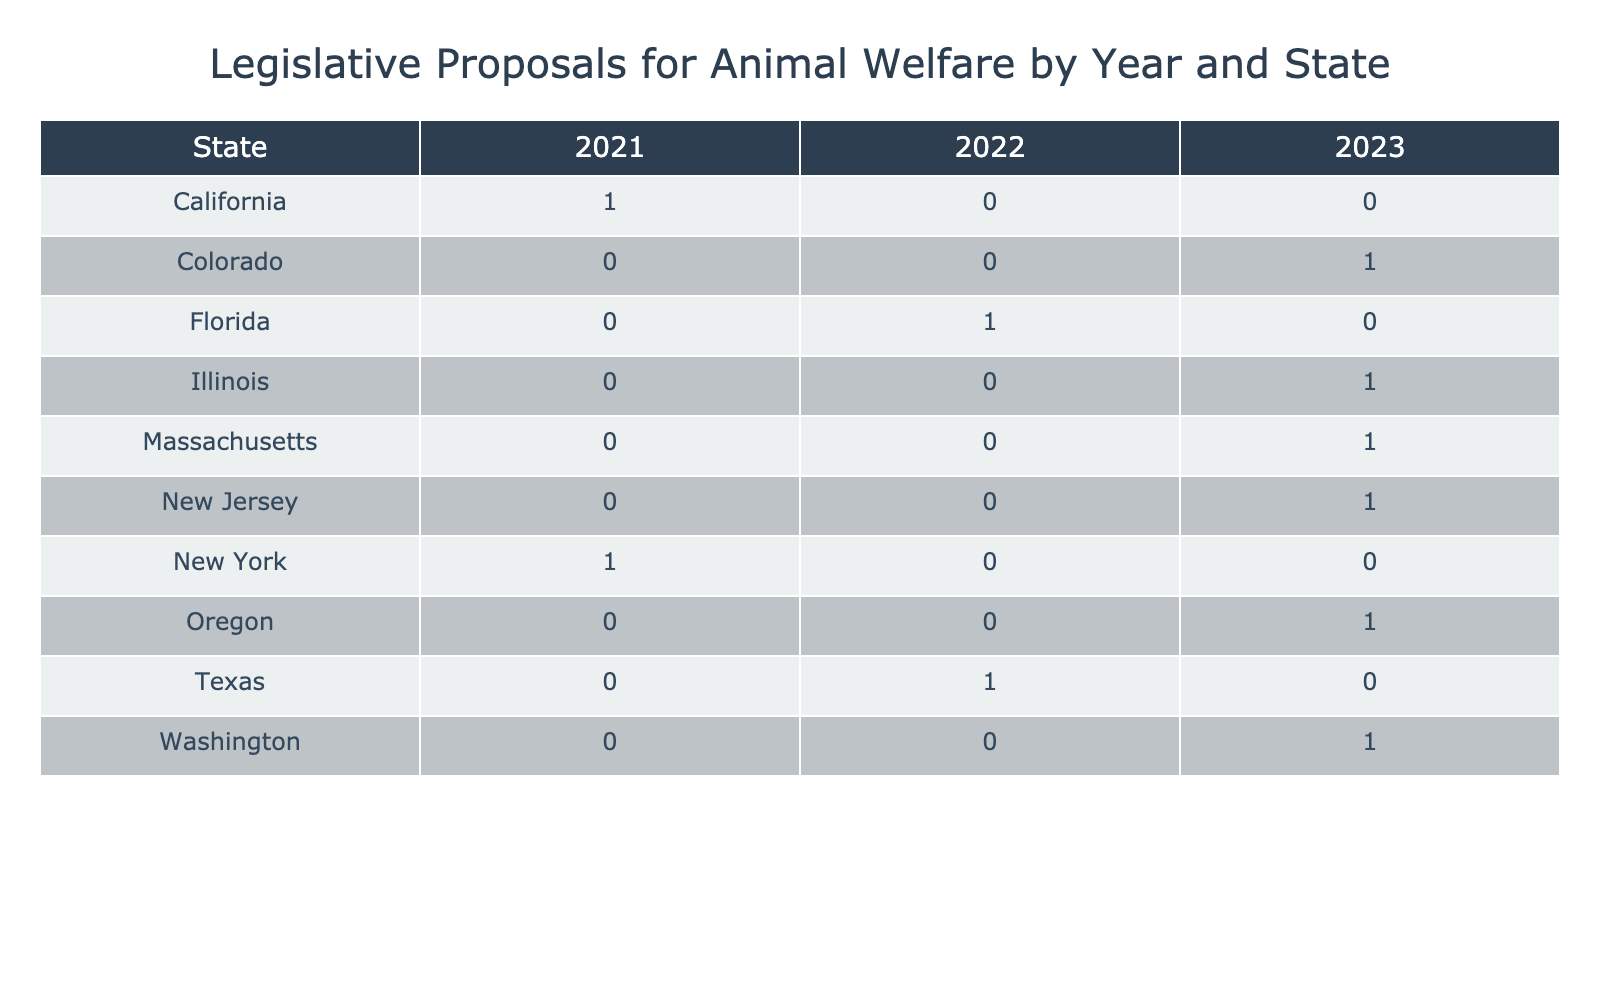What is the total number of animal welfare proposals from California in 2021? In 2021, California has only one proposal listed in the table, the Pet Protection Act. Therefore, the total number of proposals from California in that year is 1.
Answer: 1 Which year had the highest number of proposals in the table? By examining the table, we can count the number of proposals per year: 2021 (2), 2022 (1), and 2023 (5). The highest number is in 2023 with 5 proposals.
Answer: 2023 What is the status of the Animal Rescue License proposal from Florida? The table indicates that the Animal Rescue License proposal from Florida is currently marked as Pending.
Answer: Pending Did any proposals from Massachusetts pass? According to the table, the Responsible Pet Ownership Initiative from Massachusetts is listed as Failed, indicating no proposals from that state passed.
Answer: No How many states have proposals that were passed in 2023? By reviewing the table for 2023, I find proposals that were Passed from Illinois, New Jersey, and Washington. That accounts for 3 states with passed proposals in 2023.
Answer: 3 What is the difference in the number of proposals between Texas in 2022 and California in 2021? Texas has 1 proposal in 2022, while California has 1 proposal in 2021. Therefore, the difference is 1 - 1 = 0.
Answer: 0 In which year did New York have a failed animal welfare proposal? The table shows that New York had an animal welfare proposal, the Animal Cruelty Prevention Act, that failed in 2021.
Answer: 2021 How many proposals in total were listed in the table for all years and states? By adding the proposals from the table: 1 (California 2021) + 1 (New York 2021) + 1 (Texas 2022) + 1 (Florida 2022) + 1 (Illinois 2023) + 1 (Oregon 2023) + 1 (Massachusetts 2023) + 1 (Washington 2023) + 1 (Colorado 2023) + 1 (New Jersey 2023), the total is 10 proposals listed in the table.
Answer: 10 Which states had proposals that were labeled as Pending? The states with pending proposals, according to the table, are Florida (Animal Rescue License) and Colorado (Pet Microchipping Regulation).
Answer: Florida, Colorado 